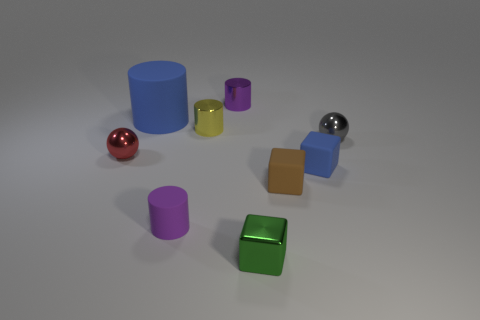Subtract all yellow cylinders. Subtract all purple cubes. How many cylinders are left? 3 Add 1 yellow cylinders. How many objects exist? 10 Subtract all balls. How many objects are left? 7 Add 6 blue blocks. How many blue blocks exist? 7 Subtract 0 brown cylinders. How many objects are left? 9 Subtract all matte cubes. Subtract all spheres. How many objects are left? 5 Add 2 tiny green metallic cubes. How many tiny green metallic cubes are left? 3 